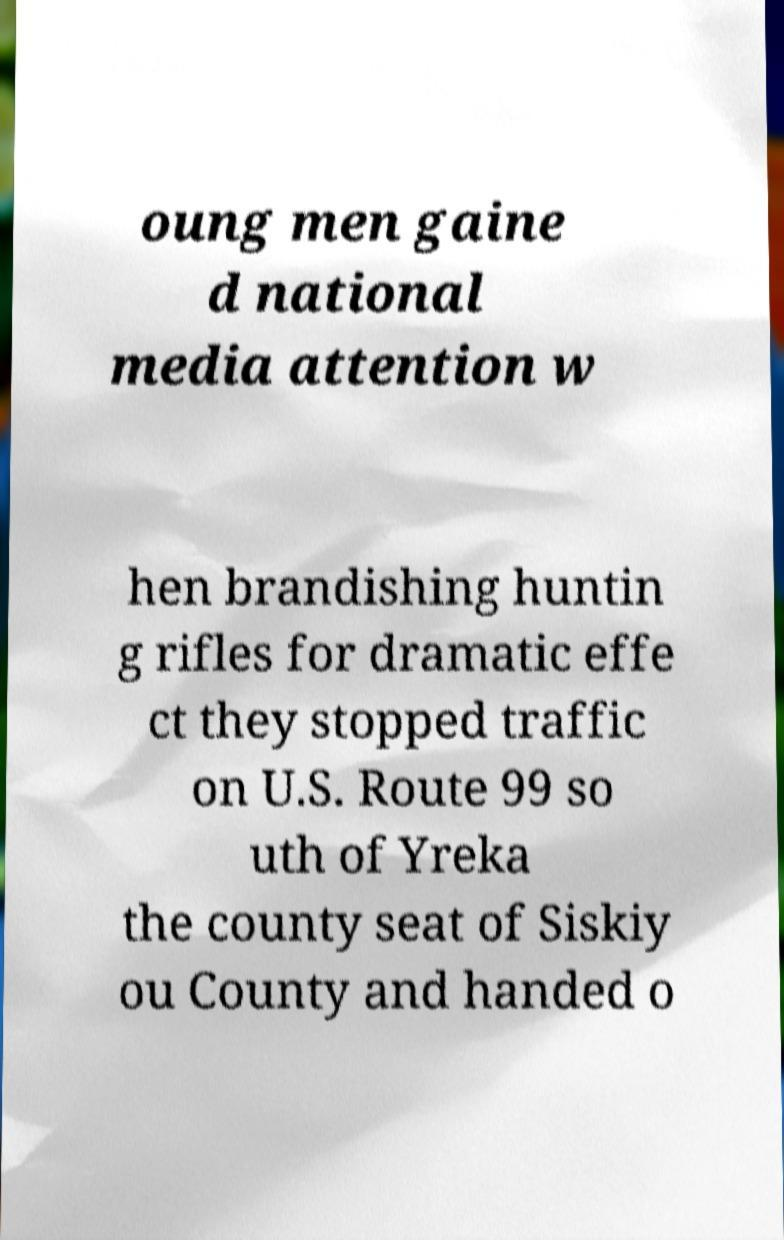Please read and relay the text visible in this image. What does it say? oung men gaine d national media attention w hen brandishing huntin g rifles for dramatic effe ct they stopped traffic on U.S. Route 99 so uth of Yreka the county seat of Siskiy ou County and handed o 